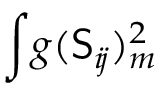Convert formula to latex. <formula><loc_0><loc_0><loc_500><loc_500>\int \, g ( S _ { i \, j } ) _ { m } ^ { 2 }</formula> 